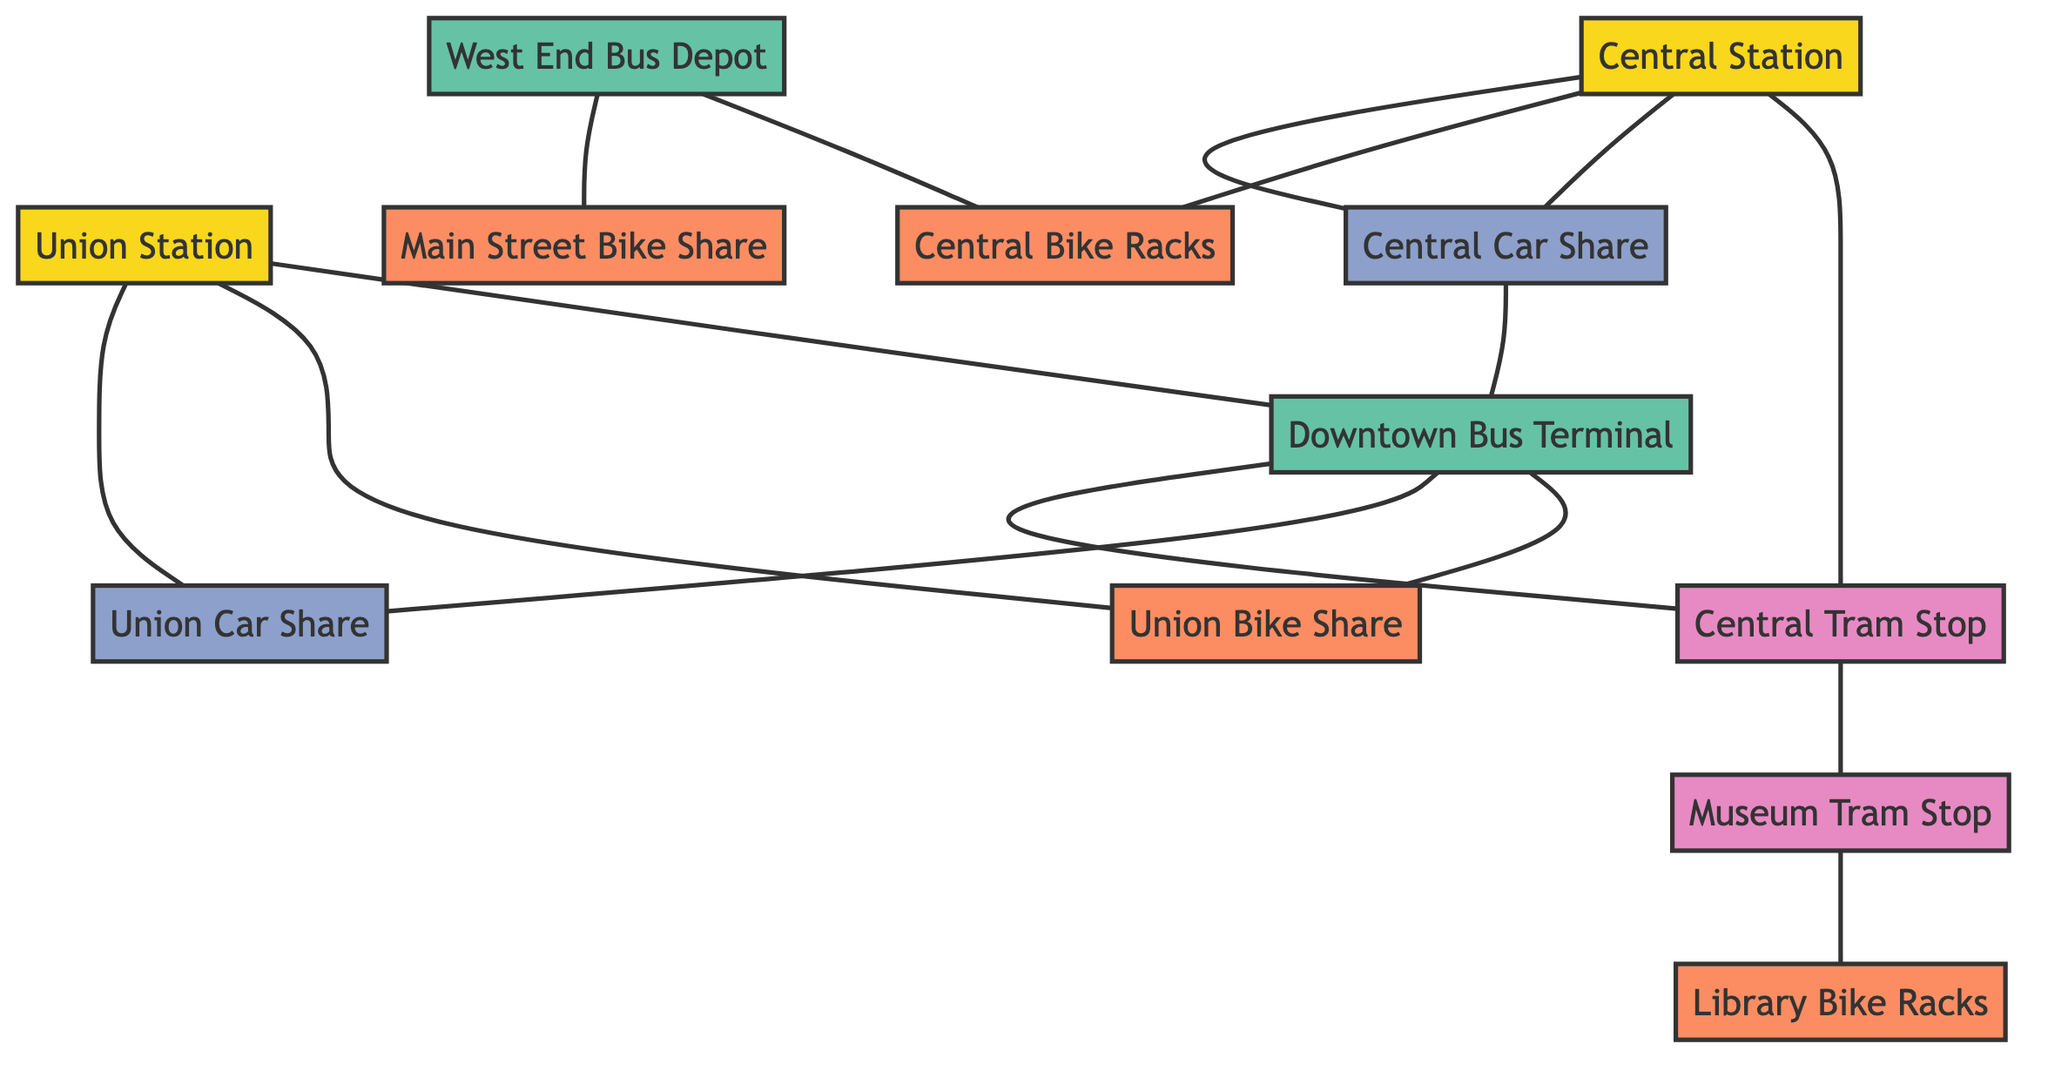What are the integration points available in the intermodal transportation network? The integration points specified in the data include Union Station, Central Station, Downtown Bus Terminal, and West End Bus Depot. These points are crucial for smooth transitions between different modes of transportation.
Answer: Union Station, Central Station, Downtown Bus Terminal, West End Bus Depot How many transfer connections does Union Station have? Union Station has three transfer connections: Bus Terminal, Bike Share, and Car Share. Each of these connections facilitates passenger transitions to other forms of transportation.
Answer: 3 What mode of transportation is connected to Central Station through the Central Tram Stop? The Central Tram Stop connects to Central Station, serving as an intermodal transfer point for passengers using tram services.
Answer: Tram Which bus terminal connects to both Union Station and Downtown Bus Terminal? The Downtown Bus Terminal is connected to both Union Station via bus and is a transfer point for other transportation options, enhancing connectivity in the network.
Answer: Downtown Bus Terminal How many bike-sharing stations are linked to Central Station? There is one bike-sharing station linked to Central Station, specifically the Main Street Bike Share, providing an additional transportation option for passengers.
Answer: 1 Which transportation nodes share the most connections at Downtown Bus Terminal? The Downtown Bus Terminal shares connections with Union Station, Tram Stop, Bike Share, and Car Share, making it a well-connected hub in the network.
Answer: Union Station, Tram Stop, Bike Share, Car Share At which facilities can passengers find restrooms? Passengers can find restrooms at Union Station, Central Station, Downtown Bus Terminal, and West End Bus Depot. These facilities are essential for passenger comfort and convenience.
Answer: Union Station, Central Station, Downtown Bus Terminal, West End Bus Depot What is the primary intermodal connection type at Central Station? The primary intermodal connection at Central Station involves railway operations, including connections to tram stops and car-sharing points, making it a pivotal transit hub.
Answer: Railway How many bike racks are associated with transfers at West End Bus Depot? The West End Bus Depot has one bike rack location associated with it, specifically the Bike Racks, which supports cyclists in transitioning to the bus service.
Answer: 1 